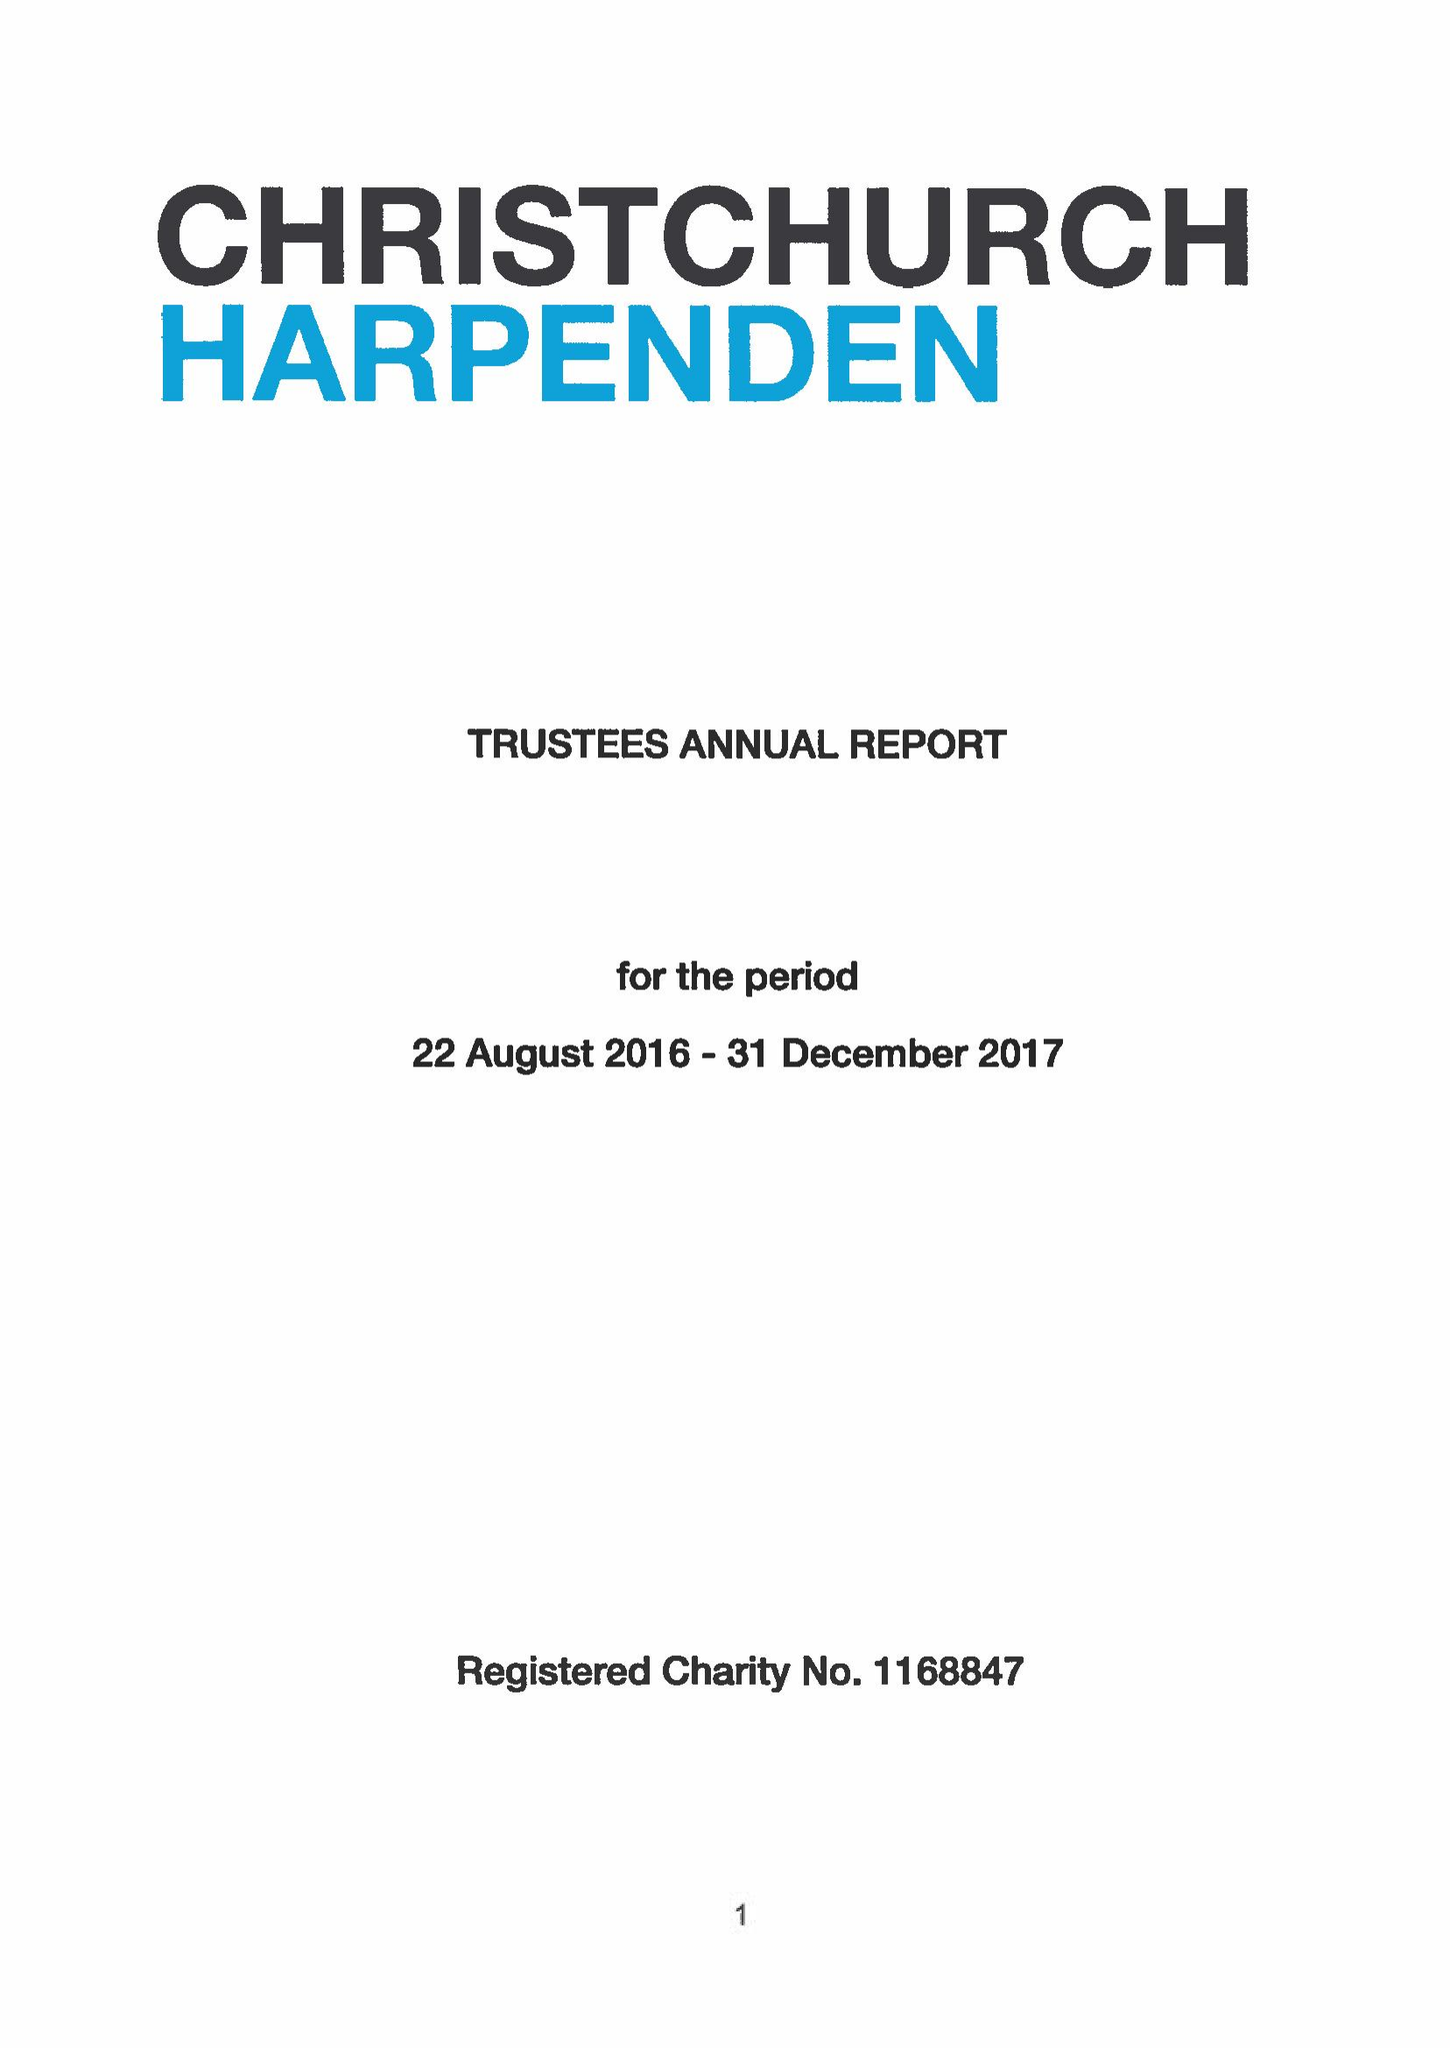What is the value for the address__post_town?
Answer the question using a single word or phrase. HARPENDEN 